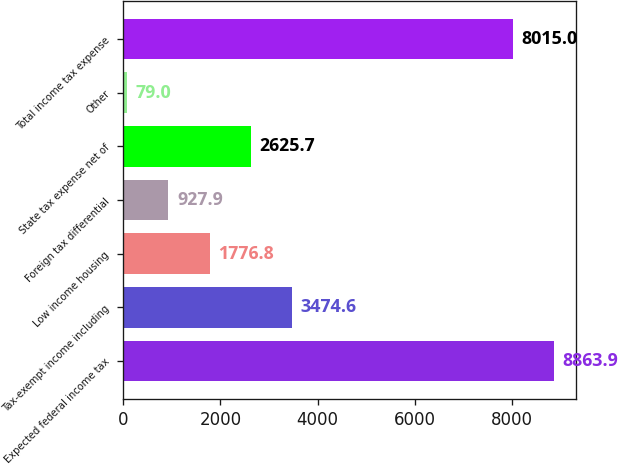<chart> <loc_0><loc_0><loc_500><loc_500><bar_chart><fcel>Expected federal income tax<fcel>Tax-exempt income including<fcel>Low income housing<fcel>Foreign tax differential<fcel>State tax expense net of<fcel>Other<fcel>Total income tax expense<nl><fcel>8863.9<fcel>3474.6<fcel>1776.8<fcel>927.9<fcel>2625.7<fcel>79<fcel>8015<nl></chart> 